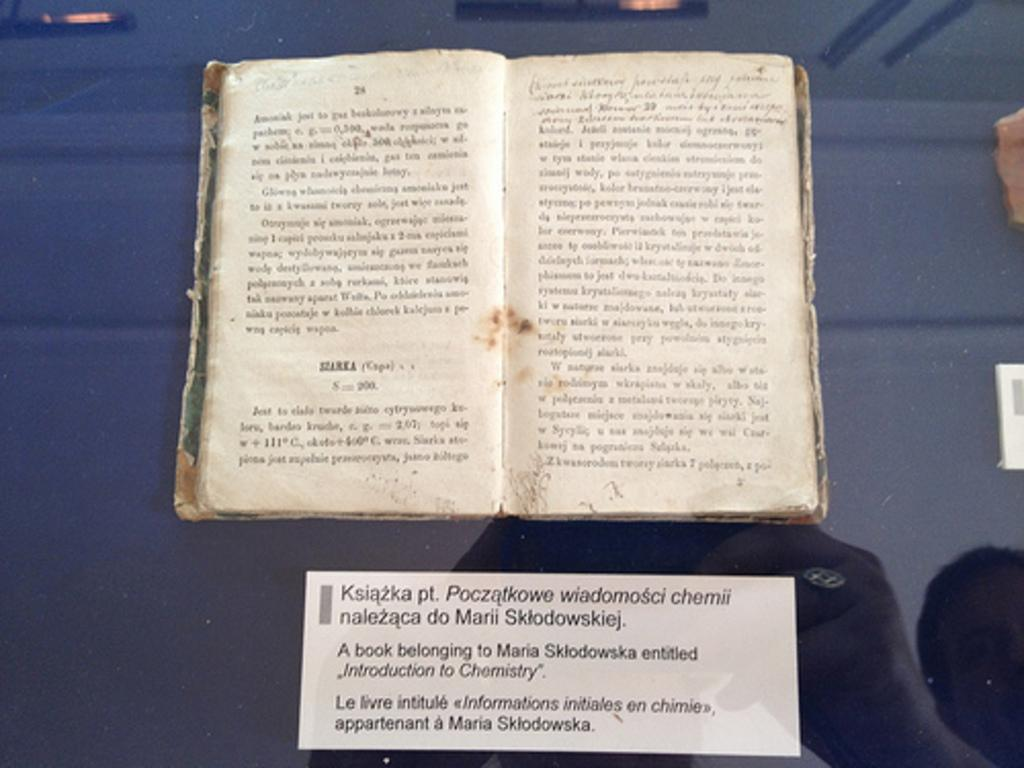<image>
Offer a succinct explanation of the picture presented. The book is in a foreign language but the section at the bottom starts with Ksiazka pt. 